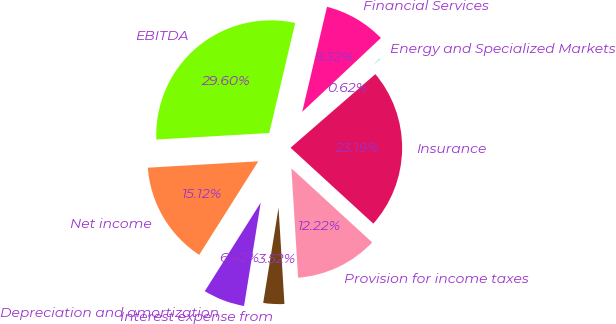<chart> <loc_0><loc_0><loc_500><loc_500><pie_chart><fcel>Insurance<fcel>Energy and Specialized Markets<fcel>Financial Services<fcel>EBITDA<fcel>Net income<fcel>Depreciation and amortization<fcel>Interest expense from<fcel>Provision for income taxes<nl><fcel>23.19%<fcel>0.62%<fcel>9.32%<fcel>29.61%<fcel>15.12%<fcel>6.42%<fcel>3.52%<fcel>12.22%<nl></chart> 